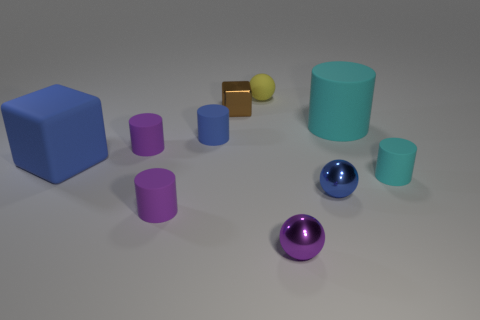Subtract all blue cylinders. How many cylinders are left? 4 Subtract all red spheres. How many purple cylinders are left? 2 Subtract 1 cubes. How many cubes are left? 1 Subtract all blocks. How many objects are left? 8 Add 5 big rubber cylinders. How many big rubber cylinders are left? 6 Add 6 large green rubber cubes. How many large green rubber cubes exist? 6 Subtract all purple spheres. How many spheres are left? 2 Subtract 0 purple blocks. How many objects are left? 10 Subtract all red cylinders. Subtract all gray spheres. How many cylinders are left? 5 Subtract all tiny shiny things. Subtract all small shiny blocks. How many objects are left? 6 